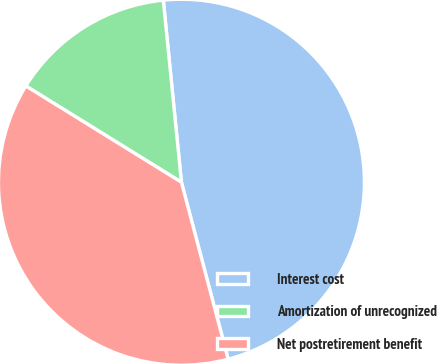<chart> <loc_0><loc_0><loc_500><loc_500><pie_chart><fcel>Interest cost<fcel>Amortization of unrecognized<fcel>Net postretirement benefit<nl><fcel>47.47%<fcel>14.6%<fcel>37.93%<nl></chart> 